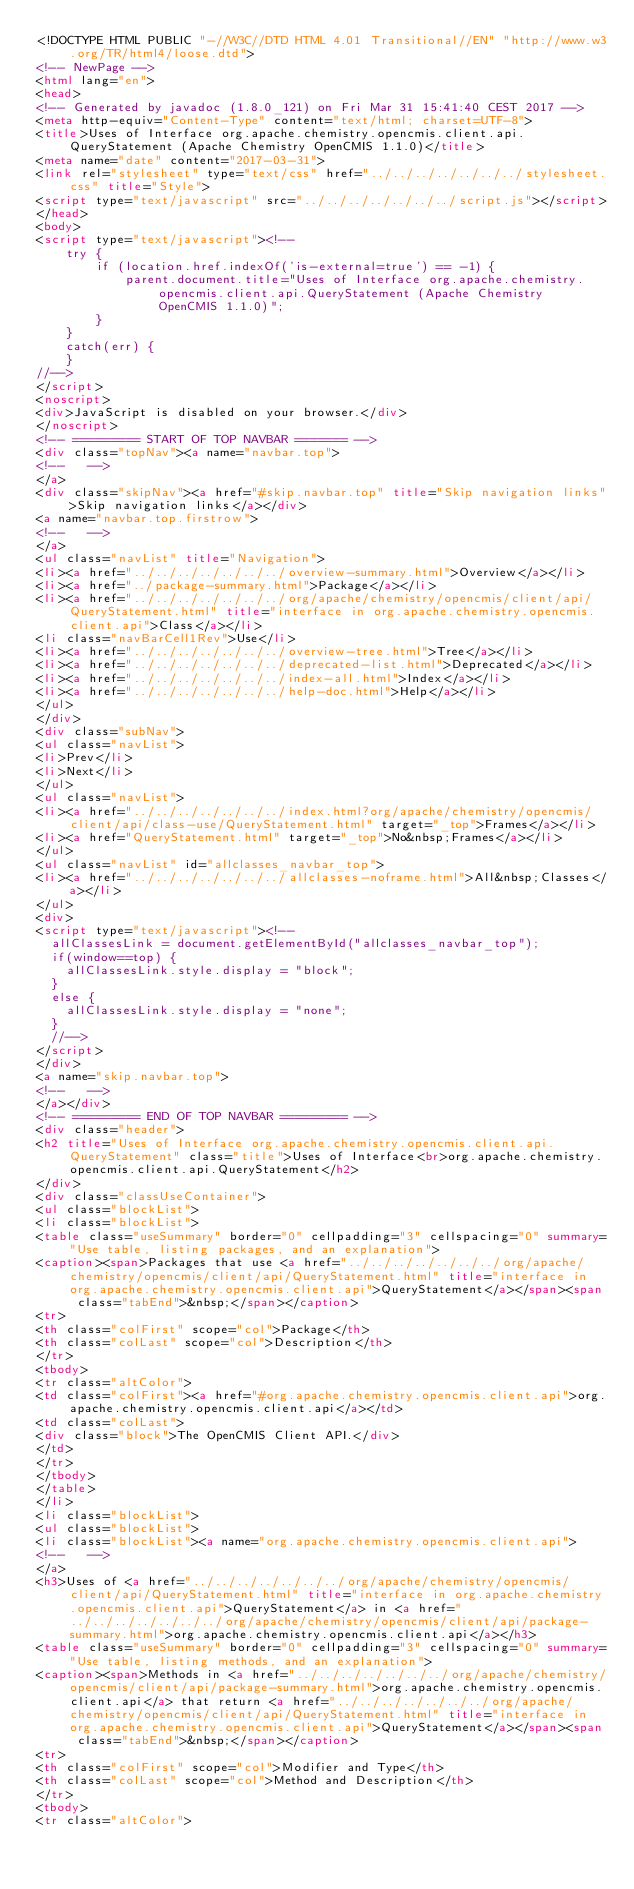Convert code to text. <code><loc_0><loc_0><loc_500><loc_500><_HTML_><!DOCTYPE HTML PUBLIC "-//W3C//DTD HTML 4.01 Transitional//EN" "http://www.w3.org/TR/html4/loose.dtd">
<!-- NewPage -->
<html lang="en">
<head>
<!-- Generated by javadoc (1.8.0_121) on Fri Mar 31 15:41:40 CEST 2017 -->
<meta http-equiv="Content-Type" content="text/html; charset=UTF-8">
<title>Uses of Interface org.apache.chemistry.opencmis.client.api.QueryStatement (Apache Chemistry OpenCMIS 1.1.0)</title>
<meta name="date" content="2017-03-31">
<link rel="stylesheet" type="text/css" href="../../../../../../../stylesheet.css" title="Style">
<script type="text/javascript" src="../../../../../../../script.js"></script>
</head>
<body>
<script type="text/javascript"><!--
    try {
        if (location.href.indexOf('is-external=true') == -1) {
            parent.document.title="Uses of Interface org.apache.chemistry.opencmis.client.api.QueryStatement (Apache Chemistry OpenCMIS 1.1.0)";
        }
    }
    catch(err) {
    }
//-->
</script>
<noscript>
<div>JavaScript is disabled on your browser.</div>
</noscript>
<!-- ========= START OF TOP NAVBAR ======= -->
<div class="topNav"><a name="navbar.top">
<!--   -->
</a>
<div class="skipNav"><a href="#skip.navbar.top" title="Skip navigation links">Skip navigation links</a></div>
<a name="navbar.top.firstrow">
<!--   -->
</a>
<ul class="navList" title="Navigation">
<li><a href="../../../../../../../overview-summary.html">Overview</a></li>
<li><a href="../package-summary.html">Package</a></li>
<li><a href="../../../../../../../org/apache/chemistry/opencmis/client/api/QueryStatement.html" title="interface in org.apache.chemistry.opencmis.client.api">Class</a></li>
<li class="navBarCell1Rev">Use</li>
<li><a href="../../../../../../../overview-tree.html">Tree</a></li>
<li><a href="../../../../../../../deprecated-list.html">Deprecated</a></li>
<li><a href="../../../../../../../index-all.html">Index</a></li>
<li><a href="../../../../../../../help-doc.html">Help</a></li>
</ul>
</div>
<div class="subNav">
<ul class="navList">
<li>Prev</li>
<li>Next</li>
</ul>
<ul class="navList">
<li><a href="../../../../../../../index.html?org/apache/chemistry/opencmis/client/api/class-use/QueryStatement.html" target="_top">Frames</a></li>
<li><a href="QueryStatement.html" target="_top">No&nbsp;Frames</a></li>
</ul>
<ul class="navList" id="allclasses_navbar_top">
<li><a href="../../../../../../../allclasses-noframe.html">All&nbsp;Classes</a></li>
</ul>
<div>
<script type="text/javascript"><!--
  allClassesLink = document.getElementById("allclasses_navbar_top");
  if(window==top) {
    allClassesLink.style.display = "block";
  }
  else {
    allClassesLink.style.display = "none";
  }
  //-->
</script>
</div>
<a name="skip.navbar.top">
<!--   -->
</a></div>
<!-- ========= END OF TOP NAVBAR ========= -->
<div class="header">
<h2 title="Uses of Interface org.apache.chemistry.opencmis.client.api.QueryStatement" class="title">Uses of Interface<br>org.apache.chemistry.opencmis.client.api.QueryStatement</h2>
</div>
<div class="classUseContainer">
<ul class="blockList">
<li class="blockList">
<table class="useSummary" border="0" cellpadding="3" cellspacing="0" summary="Use table, listing packages, and an explanation">
<caption><span>Packages that use <a href="../../../../../../../org/apache/chemistry/opencmis/client/api/QueryStatement.html" title="interface in org.apache.chemistry.opencmis.client.api">QueryStatement</a></span><span class="tabEnd">&nbsp;</span></caption>
<tr>
<th class="colFirst" scope="col">Package</th>
<th class="colLast" scope="col">Description</th>
</tr>
<tbody>
<tr class="altColor">
<td class="colFirst"><a href="#org.apache.chemistry.opencmis.client.api">org.apache.chemistry.opencmis.client.api</a></td>
<td class="colLast">
<div class="block">The OpenCMIS Client API.</div>
</td>
</tr>
</tbody>
</table>
</li>
<li class="blockList">
<ul class="blockList">
<li class="blockList"><a name="org.apache.chemistry.opencmis.client.api">
<!--   -->
</a>
<h3>Uses of <a href="../../../../../../../org/apache/chemistry/opencmis/client/api/QueryStatement.html" title="interface in org.apache.chemistry.opencmis.client.api">QueryStatement</a> in <a href="../../../../../../../org/apache/chemistry/opencmis/client/api/package-summary.html">org.apache.chemistry.opencmis.client.api</a></h3>
<table class="useSummary" border="0" cellpadding="3" cellspacing="0" summary="Use table, listing methods, and an explanation">
<caption><span>Methods in <a href="../../../../../../../org/apache/chemistry/opencmis/client/api/package-summary.html">org.apache.chemistry.opencmis.client.api</a> that return <a href="../../../../../../../org/apache/chemistry/opencmis/client/api/QueryStatement.html" title="interface in org.apache.chemistry.opencmis.client.api">QueryStatement</a></span><span class="tabEnd">&nbsp;</span></caption>
<tr>
<th class="colFirst" scope="col">Modifier and Type</th>
<th class="colLast" scope="col">Method and Description</th>
</tr>
<tbody>
<tr class="altColor"></code> 